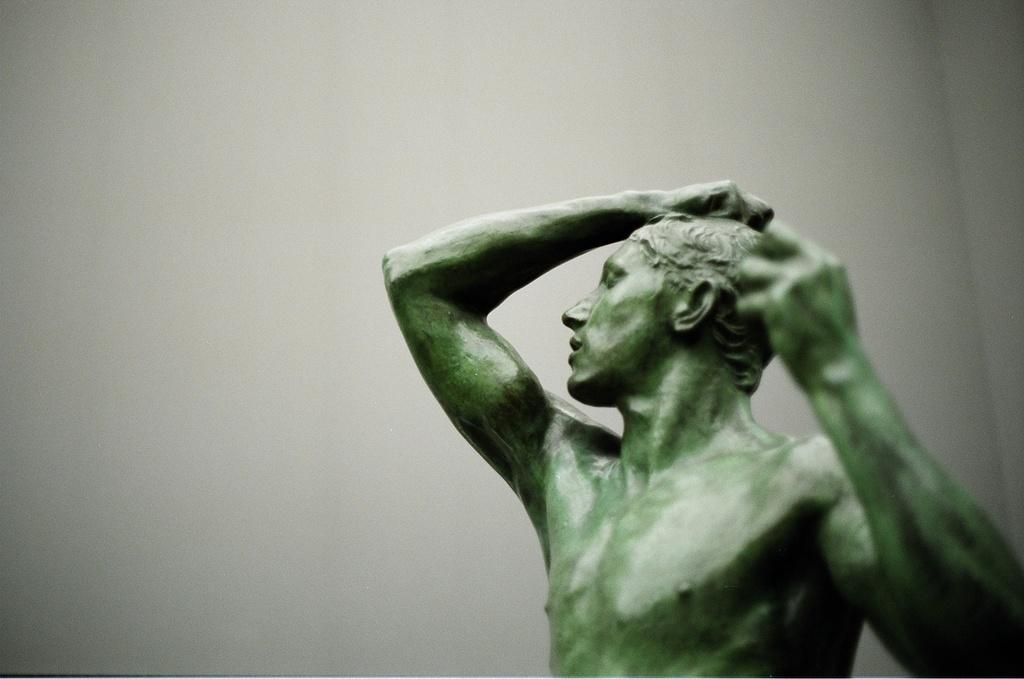What is the main subject of the image? There is a sculpture of a man in the image. Where is the sculpture located in the image? The sculpture is located towards the bottom of the image. What can be seen in the background of the image? There is a wall in the background of the image. What is the color of the background in the image? The background of the image is white in color. How does the jar start swinging in the image? There is no jar or swinging motion present in the image; it features a sculpture of a man and a white background. 